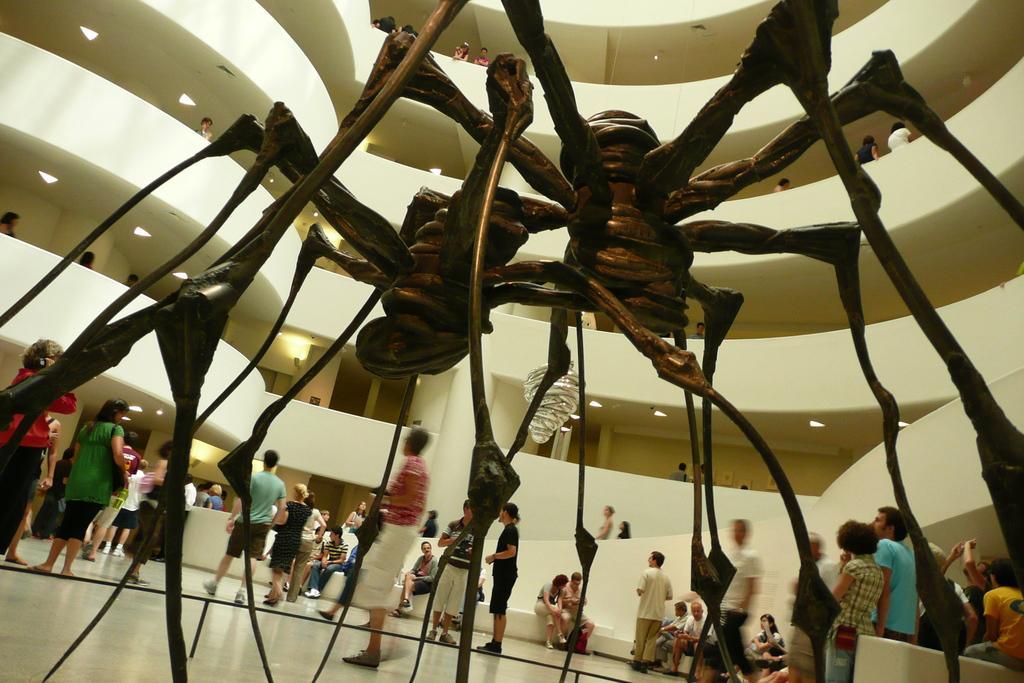Describe this image in one or two sentences. These are the things which are in the shape of spiders, there are many people who are standing this place. 